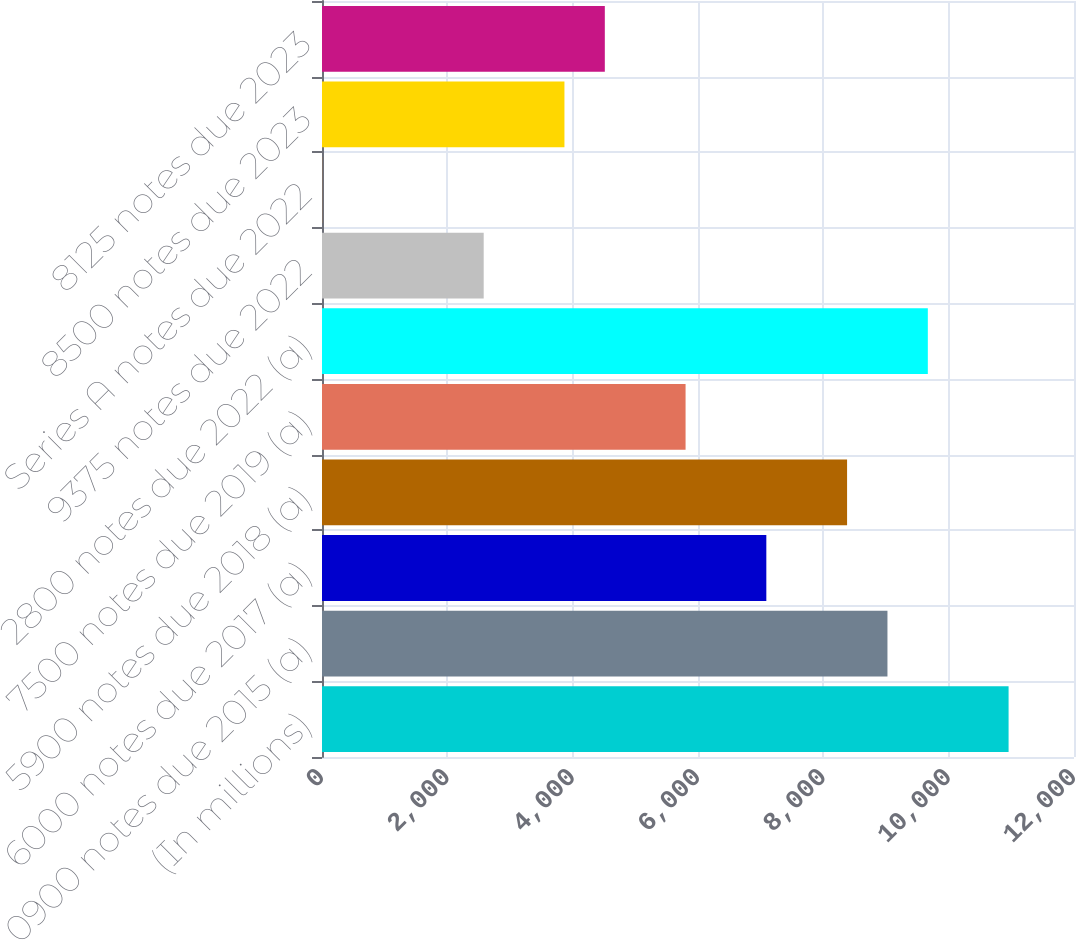Convert chart to OTSL. <chart><loc_0><loc_0><loc_500><loc_500><bar_chart><fcel>(In millions)<fcel>0900 notes due 2015 (a)<fcel>6000 notes due 2017 (a)<fcel>5900 notes due 2018 (a)<fcel>7500 notes due 2019 (a)<fcel>2800 notes due 2022 (a)<fcel>9375 notes due 2022<fcel>Series A notes due 2022<fcel>8500 notes due 2023<fcel>8125 notes due 2023<nl><fcel>10956.1<fcel>9023.2<fcel>7090.3<fcel>8378.9<fcel>5801.7<fcel>9667.5<fcel>2580.2<fcel>3<fcel>3868.8<fcel>4513.1<nl></chart> 